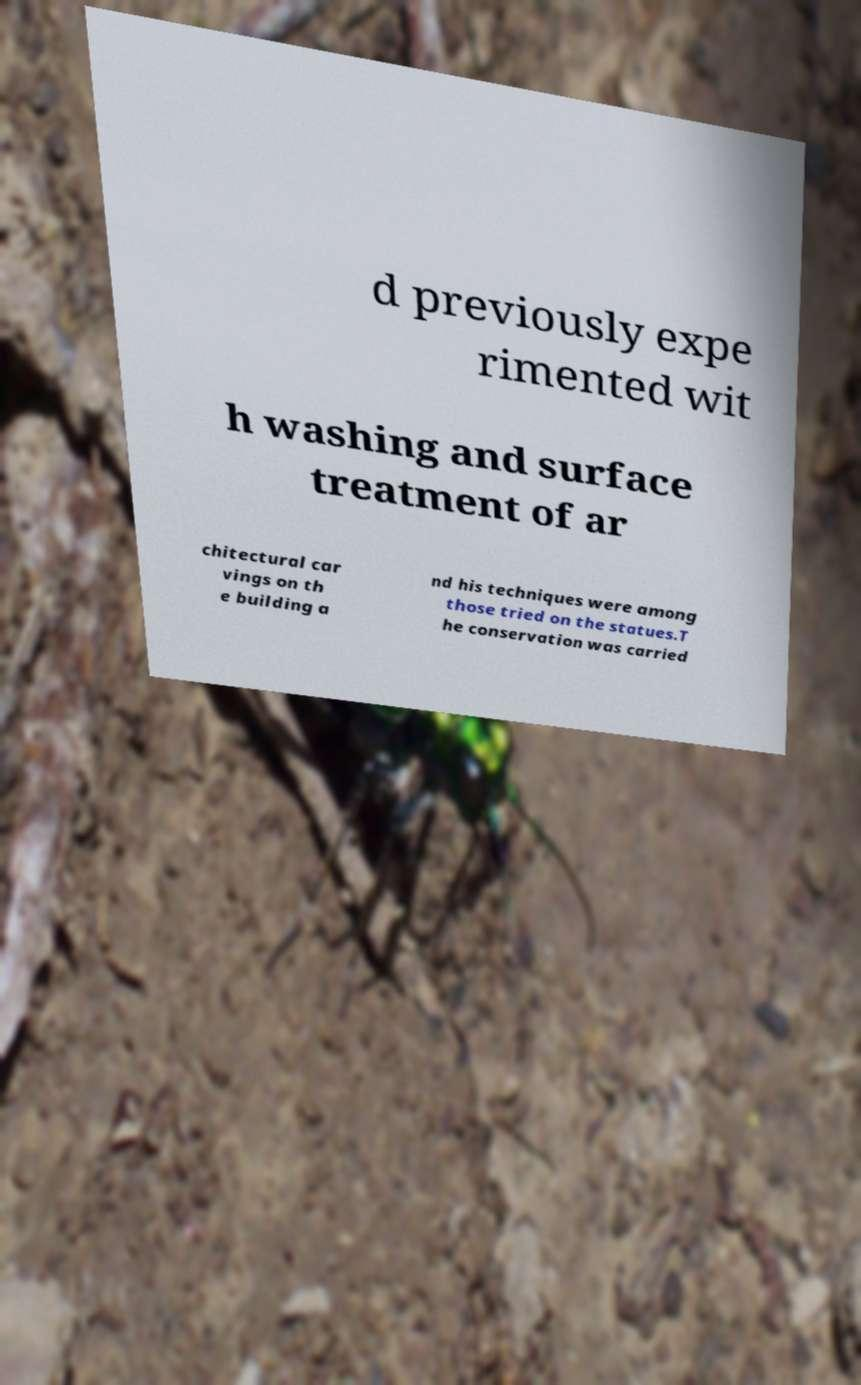For documentation purposes, I need the text within this image transcribed. Could you provide that? d previously expe rimented wit h washing and surface treatment of ar chitectural car vings on th e building a nd his techniques were among those tried on the statues.T he conservation was carried 